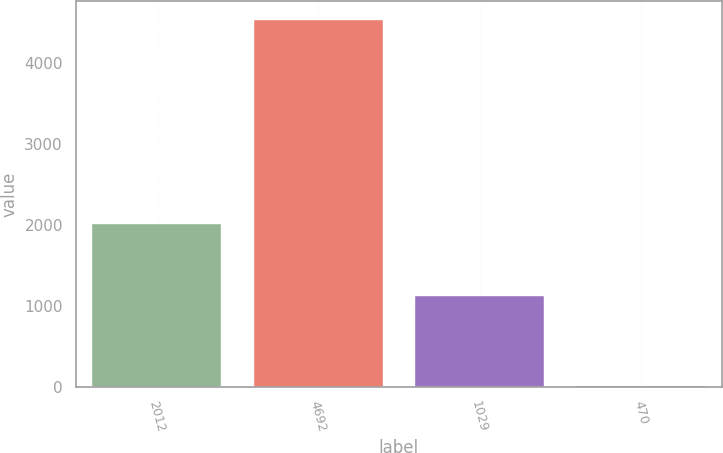<chart> <loc_0><loc_0><loc_500><loc_500><bar_chart><fcel>2012<fcel>4692<fcel>1029<fcel>470<nl><fcel>2011<fcel>4537<fcel>1116<fcel>4.62<nl></chart> 